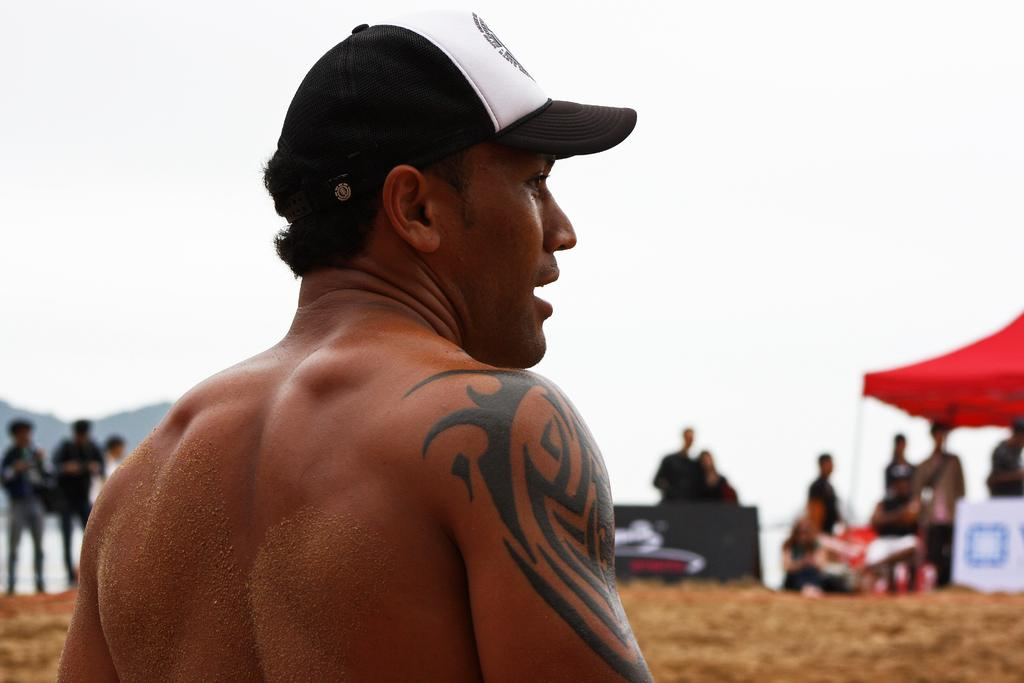Who or what can be seen in the image? There are people in the image. What structure is present in the image? There is a tent in the image. What part of the natural environment is visible in the image? The sky is visible in the image. What type of board is being used by the people in the image? There is no board present in the image. Can you see a train in the image? No, there is no train visible in the image. 